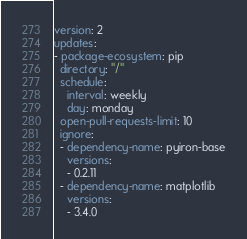<code> <loc_0><loc_0><loc_500><loc_500><_YAML_>version: 2
updates:
- package-ecosystem: pip
  directory: "/"
  schedule:
    interval: weekly
    day: monday
  open-pull-requests-limit: 10
  ignore:
  - dependency-name: pyiron-base
    versions:
    - 0.2.11
  - dependency-name: matplotlib
    versions:
    - 3.4.0
</code> 